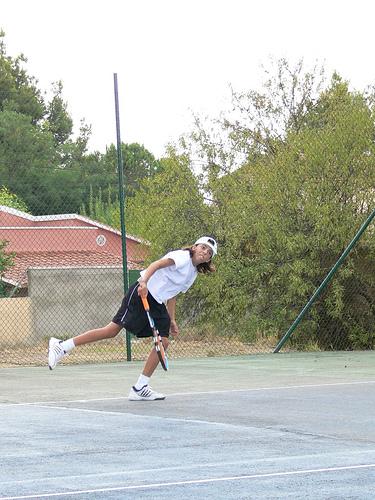What game is this?
Be succinct. Tennis. Can you see the ball?
Give a very brief answer. No. Which leg is in the air?
Quick response, please. Right. What are these people doing?
Keep it brief. Playing tennis. 